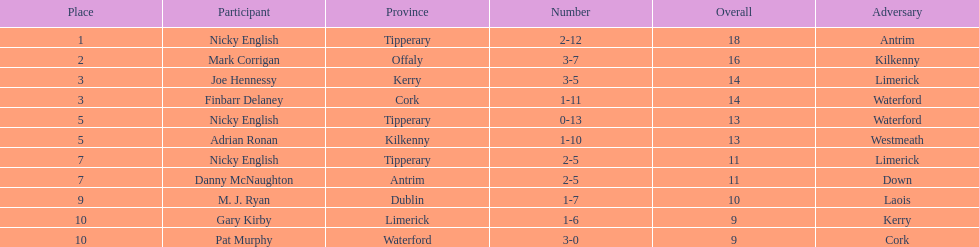Could you parse the entire table? {'header': ['Place', 'Participant', 'Province', 'Number', 'Overall', 'Adversary'], 'rows': [['1', 'Nicky English', 'Tipperary', '2-12', '18', 'Antrim'], ['2', 'Mark Corrigan', 'Offaly', '3-7', '16', 'Kilkenny'], ['3', 'Joe Hennessy', 'Kerry', '3-5', '14', 'Limerick'], ['3', 'Finbarr Delaney', 'Cork', '1-11', '14', 'Waterford'], ['5', 'Nicky English', 'Tipperary', '0-13', '13', 'Waterford'], ['5', 'Adrian Ronan', 'Kilkenny', '1-10', '13', 'Westmeath'], ['7', 'Nicky English', 'Tipperary', '2-5', '11', 'Limerick'], ['7', 'Danny McNaughton', 'Antrim', '2-5', '11', 'Down'], ['9', 'M. J. Ryan', 'Dublin', '1-7', '10', 'Laois'], ['10', 'Gary Kirby', 'Limerick', '1-6', '9', 'Kerry'], ['10', 'Pat Murphy', 'Waterford', '3-0', '9', 'Cork']]} How many times was waterford the opposition? 2. 